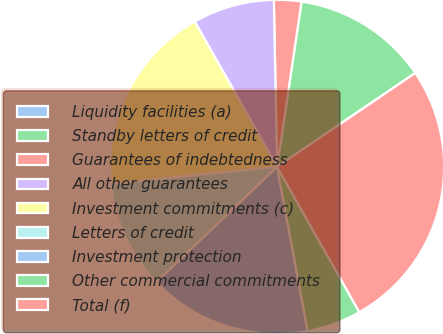Convert chart. <chart><loc_0><loc_0><loc_500><loc_500><pie_chart><fcel>Liquidity facilities (a)<fcel>Standby letters of credit<fcel>Guarantees of indebtedness<fcel>All other guarantees<fcel>Investment commitments (c)<fcel>Letters of credit<fcel>Investment protection<fcel>Other commercial commitments<fcel>Total (f)<nl><fcel>0.02%<fcel>13.15%<fcel>2.65%<fcel>7.9%<fcel>18.41%<fcel>10.53%<fcel>15.78%<fcel>5.27%<fcel>26.29%<nl></chart> 